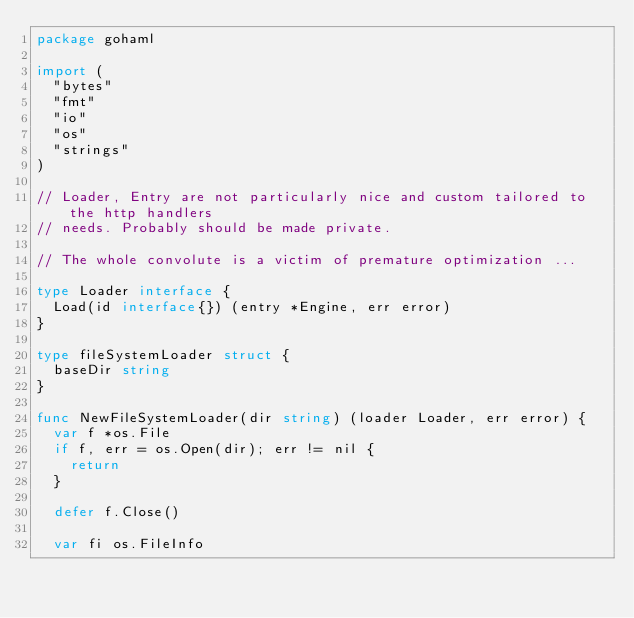Convert code to text. <code><loc_0><loc_0><loc_500><loc_500><_Go_>package gohaml

import (
	"bytes"
	"fmt"
	"io"
	"os"
	"strings"
)

// Loader, Entry are not particularly nice and custom tailored to the http handlers
// needs. Probably should be made private.

// The whole convolute is a victim of premature optimization ...

type Loader interface {
	Load(id interface{}) (entry *Engine, err error)
}

type fileSystemLoader struct {
	baseDir string
}

func NewFileSystemLoader(dir string) (loader Loader, err error) {
	var f *os.File
	if f, err = os.Open(dir); err != nil {
		return
	}

	defer f.Close()

	var fi os.FileInfo</code> 